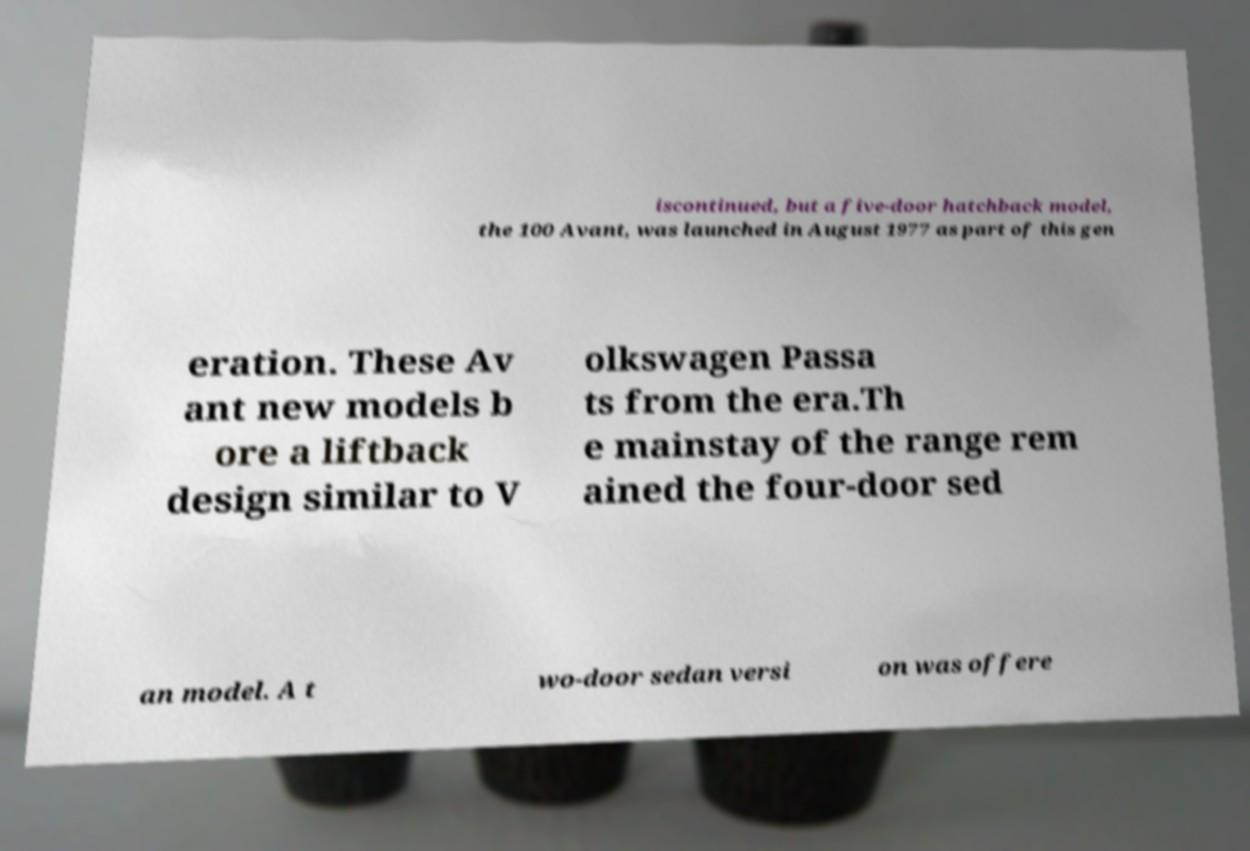Please identify and transcribe the text found in this image. iscontinued, but a five-door hatchback model, the 100 Avant, was launched in August 1977 as part of this gen eration. These Av ant new models b ore a liftback design similar to V olkswagen Passa ts from the era.Th e mainstay of the range rem ained the four-door sed an model. A t wo-door sedan versi on was offere 